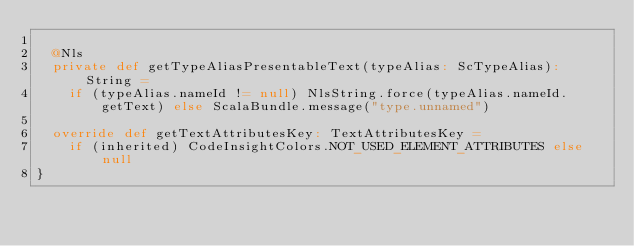<code> <loc_0><loc_0><loc_500><loc_500><_Scala_>
  @Nls
  private def getTypeAliasPresentableText(typeAlias: ScTypeAlias): String =
    if (typeAlias.nameId != null) NlsString.force(typeAlias.nameId.getText) else ScalaBundle.message("type.unnamed")

  override def getTextAttributesKey: TextAttributesKey =
    if (inherited) CodeInsightColors.NOT_USED_ELEMENT_ATTRIBUTES else null
}
</code> 